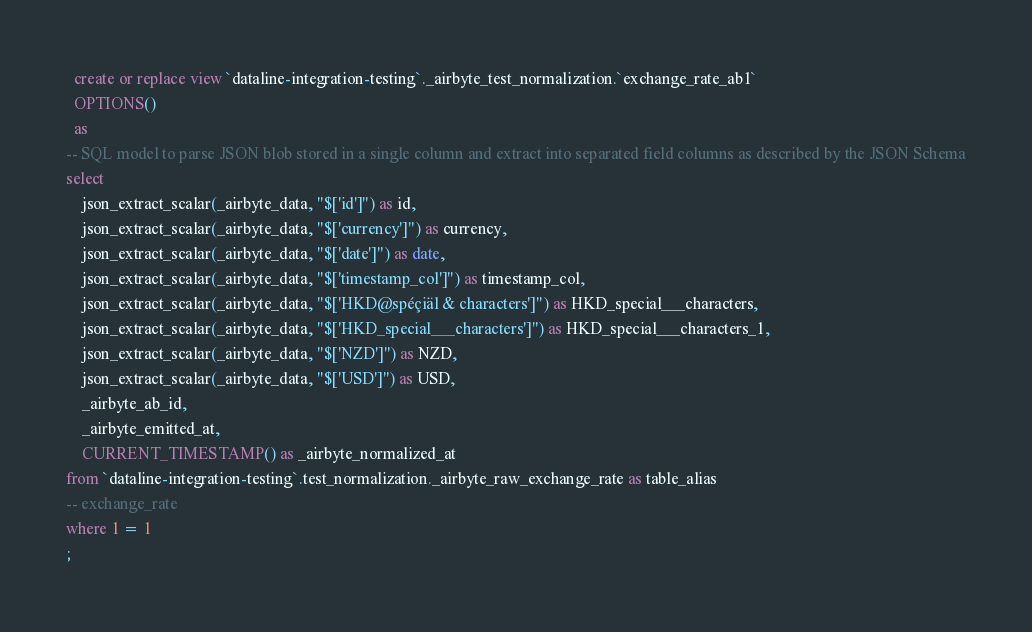<code> <loc_0><loc_0><loc_500><loc_500><_SQL_>

  create or replace view `dataline-integration-testing`._airbyte_test_normalization.`exchange_rate_ab1`
  OPTIONS()
  as 
-- SQL model to parse JSON blob stored in a single column and extract into separated field columns as described by the JSON Schema
select
    json_extract_scalar(_airbyte_data, "$['id']") as id,
    json_extract_scalar(_airbyte_data, "$['currency']") as currency,
    json_extract_scalar(_airbyte_data, "$['date']") as date,
    json_extract_scalar(_airbyte_data, "$['timestamp_col']") as timestamp_col,
    json_extract_scalar(_airbyte_data, "$['HKD@spéçiäl & characters']") as HKD_special___characters,
    json_extract_scalar(_airbyte_data, "$['HKD_special___characters']") as HKD_special___characters_1,
    json_extract_scalar(_airbyte_data, "$['NZD']") as NZD,
    json_extract_scalar(_airbyte_data, "$['USD']") as USD,
    _airbyte_ab_id,
    _airbyte_emitted_at,
    CURRENT_TIMESTAMP() as _airbyte_normalized_at
from `dataline-integration-testing`.test_normalization._airbyte_raw_exchange_rate as table_alias
-- exchange_rate
where 1 = 1
;

</code> 